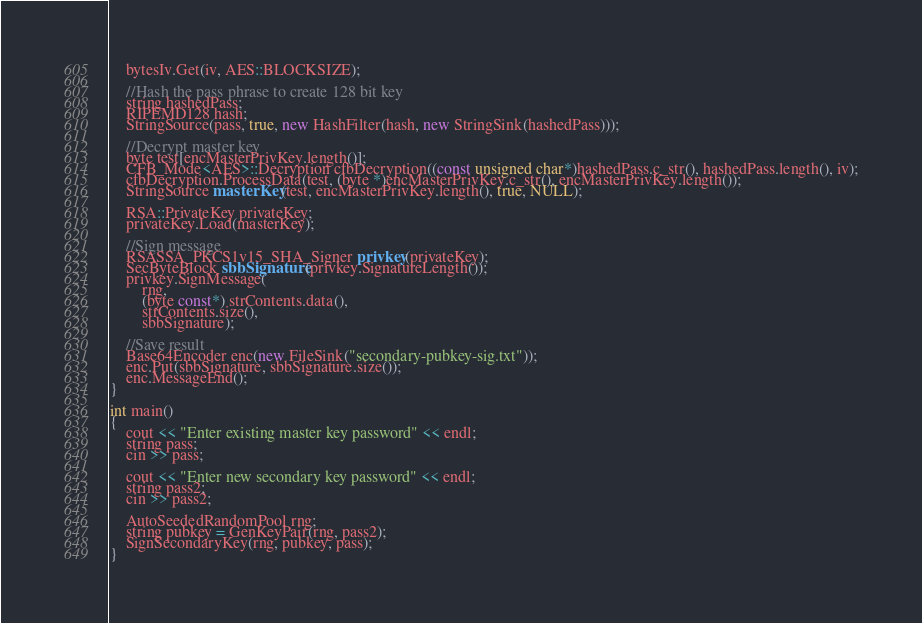<code> <loc_0><loc_0><loc_500><loc_500><_C++_>	bytesIv.Get(iv, AES::BLOCKSIZE);

	//Hash the pass phrase to create 128 bit key
	string hashedPass;
	RIPEMD128 hash;
	StringSource(pass, true, new HashFilter(hash, new StringSink(hashedPass)));

	//Decrypt master key
	byte test[encMasterPrivKey.length()];
	CFB_Mode<AES>::Decryption cfbDecryption((const unsigned char*)hashedPass.c_str(), hashedPass.length(), iv);
	cfbDecryption.ProcessData(test, (byte *)encMasterPrivKey.c_str(), encMasterPrivKey.length());
	StringSource masterKey(test, encMasterPrivKey.length(), true, NULL);

	RSA::PrivateKey privateKey;
	privateKey.Load(masterKey);

	//Sign message
	RSASSA_PKCS1v15_SHA_Signer privkey(privateKey);
	SecByteBlock sbbSignature(privkey.SignatureLength());
	privkey.SignMessage(
		rng,
		(byte const*) strContents.data(),
		strContents.size(),
		sbbSignature);

	//Save result
	Base64Encoder enc(new FileSink("secondary-pubkey-sig.txt"));
	enc.Put(sbbSignature, sbbSignature.size());
	enc.MessageEnd();
}

int main()
{
	cout << "Enter existing master key password" << endl;
	string pass;
	cin >> pass;

	cout << "Enter new secondary key password" << endl;
	string pass2;
	cin >> pass2;

	AutoSeededRandomPool rng;
	string pubkey = GenKeyPair(rng, pass2);
	SignSecondaryKey(rng, pubkey, pass);
}


</code> 